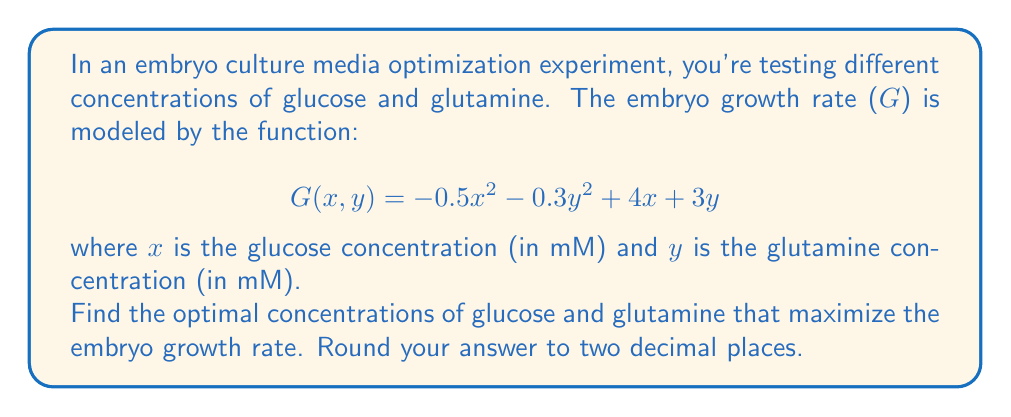Can you solve this math problem? To find the optimal concentrations that maximize the embryo growth rate, we need to find the maximum of the function $G(x, y)$. This can be done by finding the critical points of the function and evaluating them.

1. First, let's find the partial derivatives of G with respect to x and y:

   $$\frac{\partial G}{\partial x} = -x + 4$$
   $$\frac{\partial G}{\partial y} = -0.6y + 3$$

2. To find the critical points, we set both partial derivatives to zero:

   $$-x + 4 = 0$$
   $$-0.6y + 3 = 0$$

3. Solving these equations:

   $$x = 4$$
   $$y = 5$$

4. To confirm this is a maximum, we can check the second partial derivatives:

   $$\frac{\partial^2 G}{\partial x^2} = -1$$
   $$\frac{\partial^2 G}{\partial y^2} = -0.6$$

   Since both second partial derivatives are negative, this critical point is indeed a maximum.

5. Therefore, the optimal concentrations are:
   
   Glucose (x): 4 mM
   Glutamine (y): 5 mM

These concentrations will maximize the embryo growth rate according to the given model.
Answer: Optimal glucose concentration: 4.00 mM
Optimal glutamine concentration: 5.00 mM 